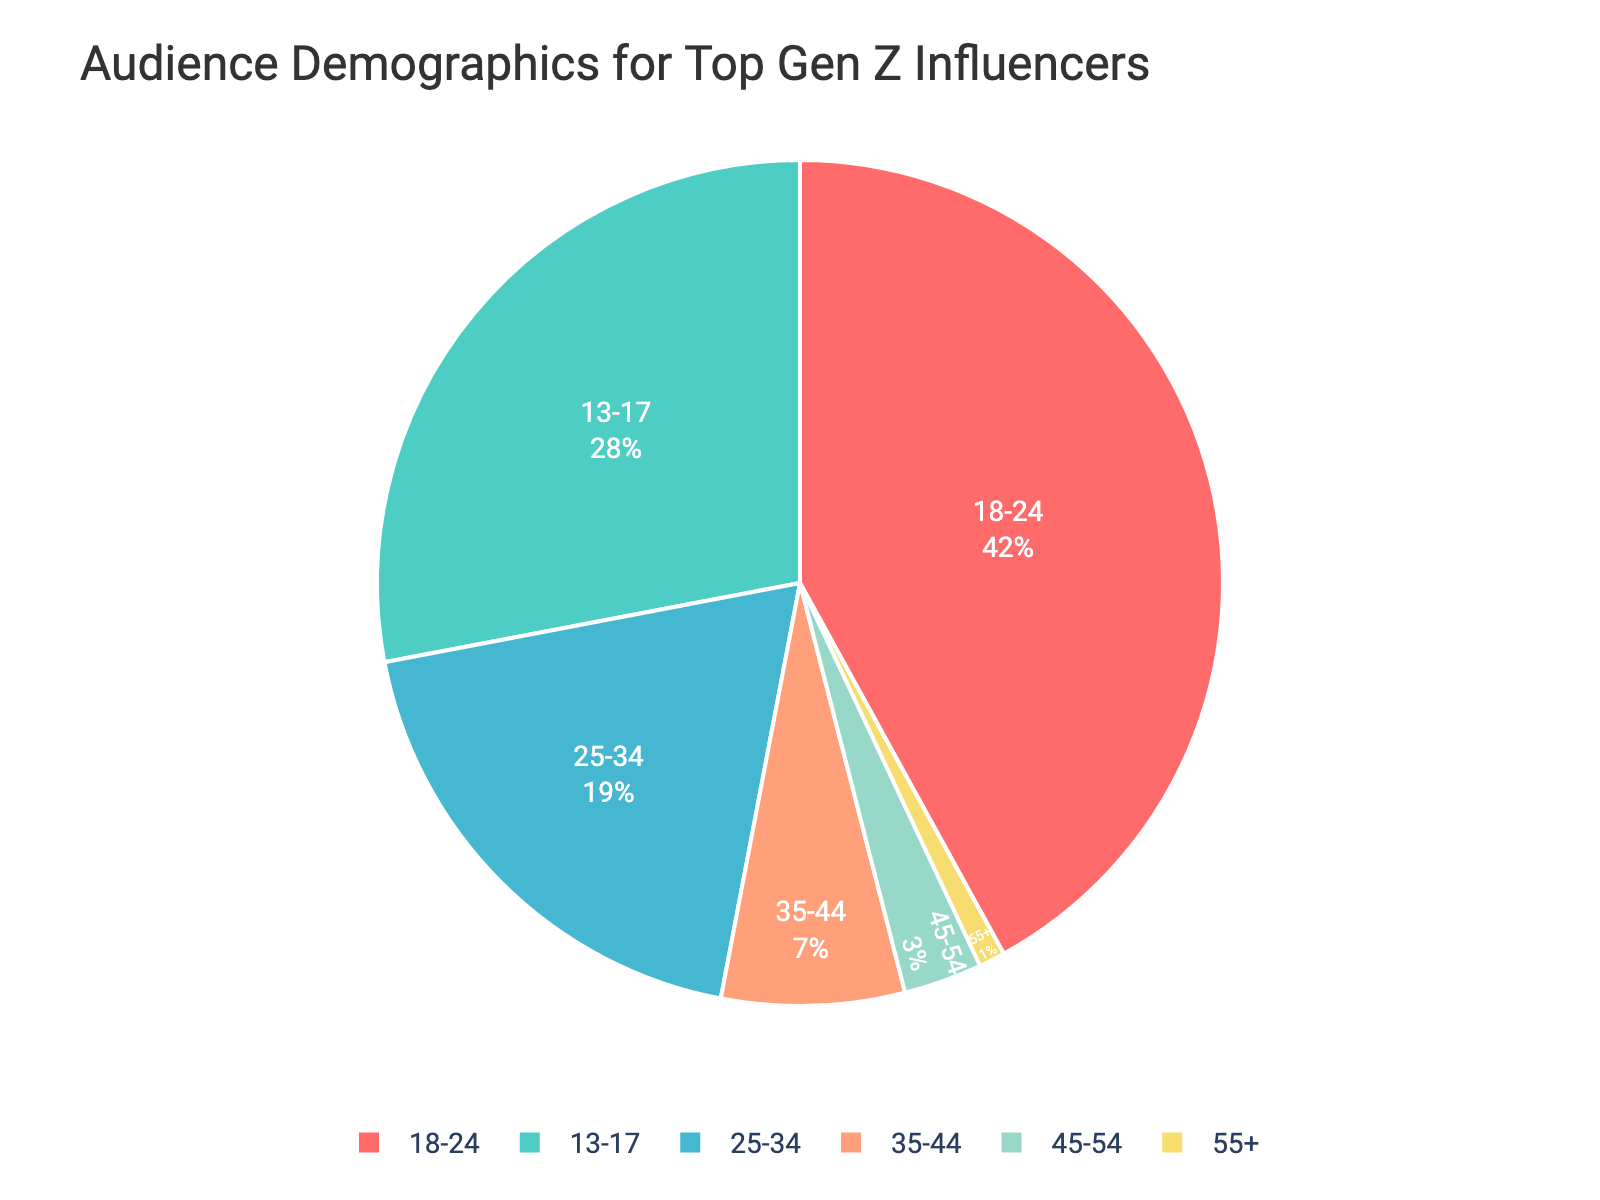What percentage of the audience is between the ages of 18 and 24? The chart displays age groups with their corresponding percentage values. The 18-24 age group is labeled with 42%.
Answer: 42% Which age group has the highest percentage of the audience? From the chart, observe the age group with the largest slice. The 18-24 age group has 42%, which is the highest.
Answer: 18-24 Which two age groups together make up half of the audience? Identify two groups whose combined percentages equal approximately 50%. The 13-17 group has 28% and the 18-24 group has 42%. However, the correct combination is 25-34 (19%) and 18-24 (42%).
Answer: 18-24 and 25-34 What is the combined percentage of the audience that is 34 years old or younger? Add the percentages for the 13-17, 18-24, and 25-34 age groups: 28% + 42% + 19% = 89%.
Answer: 89% Which age group represents the smallest portion of the audience? Look for the smallest slice on the pie chart. The 55+ group is the smallest, with 1%.
Answer: 55+ How much larger is the audience percentage of the 18-24 age group than the 35-44 age group? Subtract the percentage for the 35-44 age group from the 18-24 age group: 42% - 7% = 35%.
Answer: 35% Compare the audience percentages of the 13-17 and 45-54 age groups. Which is larger and by how much? Subtract the percentage for the 45-54 age group from the 13-17 age group: 28% - 3% = 25%. The 13-17 age group is larger by 25%.
Answer: 13-17 by 25% What is the total percentage of the audience that is 44 years old or younger? Add the percentages for the 13-17, 18-24, 25-34, and 35-44 age groups: 28% + 42% + 19% + 7% = 96%.
Answer: 96% Which age group is represented by the light blue color in the chart? The chart uses specific colors for each age group. The light blue color typically maps to a specific group, here representing the 45-54 age group.
Answer: 45-54 If you were to target content for the two largest age groups, which groups would you focus on? Identify the two largest slices/age groups. The 18-24 and 13-17 age groups are the two largest, with 42% and 28%, respectively.
Answer: 18-24 and 13-17 